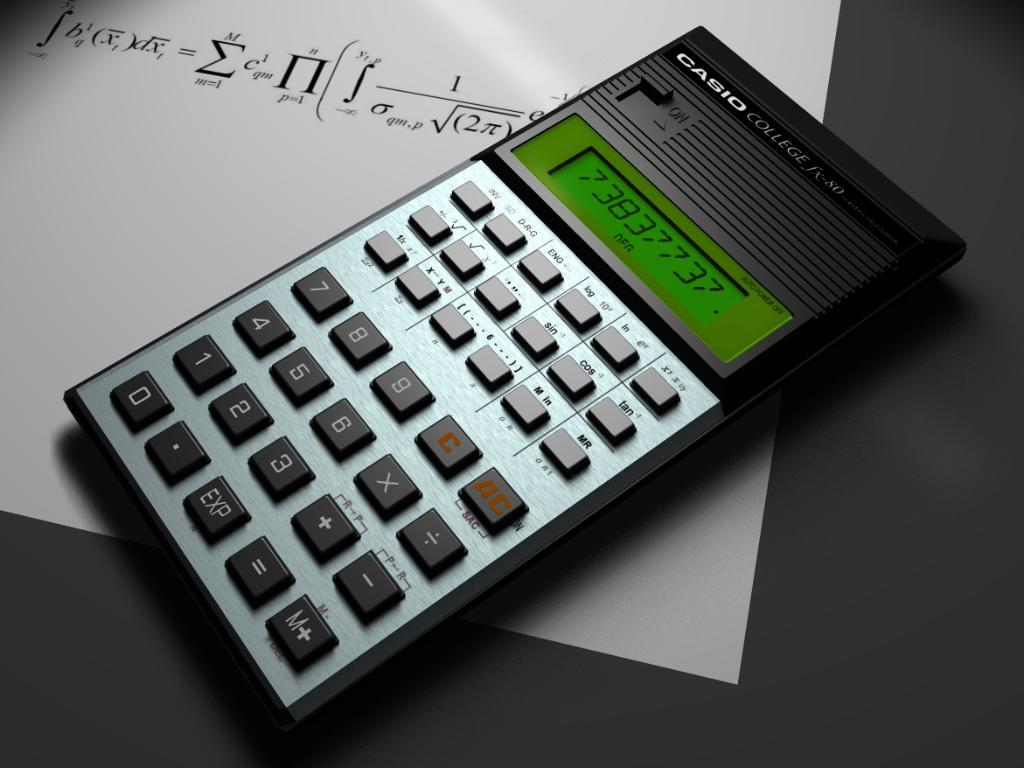<image>
Offer a succinct explanation of the picture presented. a calculator has the number 3 on it 